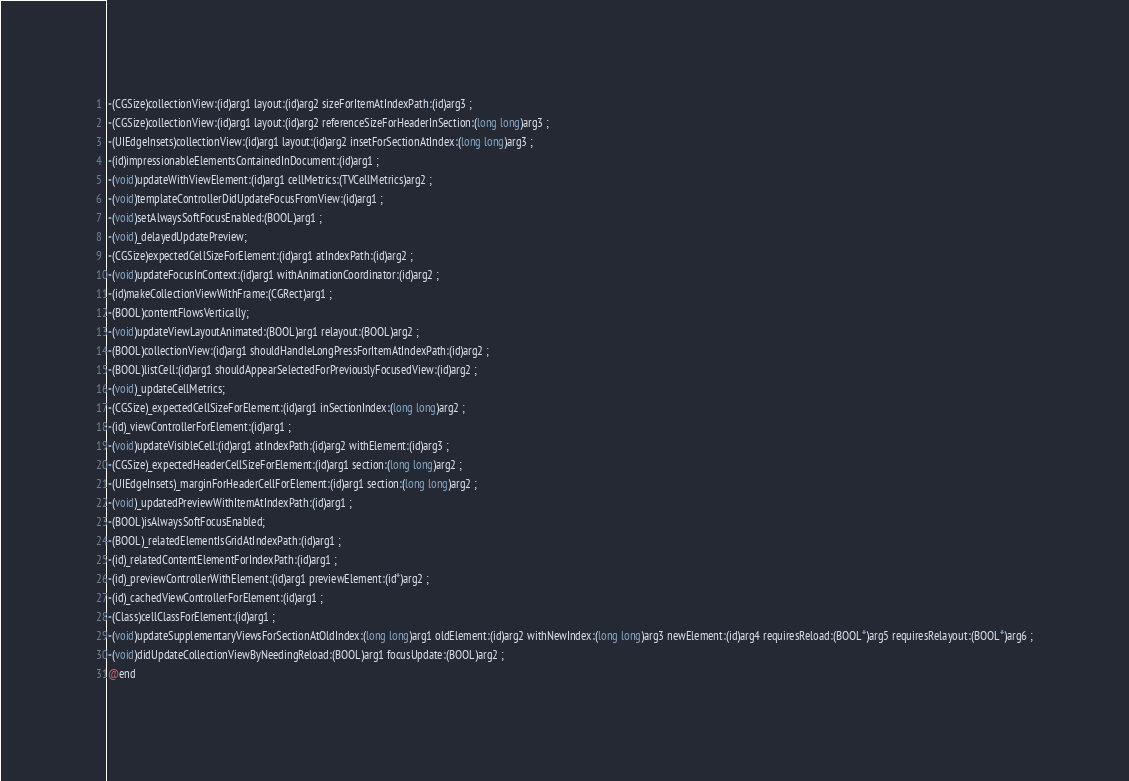Convert code to text. <code><loc_0><loc_0><loc_500><loc_500><_C_>-(CGSize)collectionView:(id)arg1 layout:(id)arg2 sizeForItemAtIndexPath:(id)arg3 ;
-(CGSize)collectionView:(id)arg1 layout:(id)arg2 referenceSizeForHeaderInSection:(long long)arg3 ;
-(UIEdgeInsets)collectionView:(id)arg1 layout:(id)arg2 insetForSectionAtIndex:(long long)arg3 ;
-(id)impressionableElementsContainedInDocument:(id)arg1 ;
-(void)updateWithViewElement:(id)arg1 cellMetrics:(TVCellMetrics)arg2 ;
-(void)templateControllerDidUpdateFocusFromView:(id)arg1 ;
-(void)setAlwaysSoftFocusEnabled:(BOOL)arg1 ;
-(void)_delayedUpdatePreview;
-(CGSize)expectedCellSizeForElement:(id)arg1 atIndexPath:(id)arg2 ;
-(void)updateFocusInContext:(id)arg1 withAnimationCoordinator:(id)arg2 ;
-(id)makeCollectionViewWithFrame:(CGRect)arg1 ;
-(BOOL)contentFlowsVertically;
-(void)updateViewLayoutAnimated:(BOOL)arg1 relayout:(BOOL)arg2 ;
-(BOOL)collectionView:(id)arg1 shouldHandleLongPressForItemAtIndexPath:(id)arg2 ;
-(BOOL)listCell:(id)arg1 shouldAppearSelectedForPreviouslyFocusedView:(id)arg2 ;
-(void)_updateCellMetrics;
-(CGSize)_expectedCellSizeForElement:(id)arg1 inSectionIndex:(long long)arg2 ;
-(id)_viewControllerForElement:(id)arg1 ;
-(void)updateVisibleCell:(id)arg1 atIndexPath:(id)arg2 withElement:(id)arg3 ;
-(CGSize)_expectedHeaderCellSizeForElement:(id)arg1 section:(long long)arg2 ;
-(UIEdgeInsets)_marginForHeaderCellForElement:(id)arg1 section:(long long)arg2 ;
-(void)_updatedPreviewWithItemAtIndexPath:(id)arg1 ;
-(BOOL)isAlwaysSoftFocusEnabled;
-(BOOL)_relatedElementIsGridAtIndexPath:(id)arg1 ;
-(id)_relatedContentElementForIndexPath:(id)arg1 ;
-(id)_previewControllerWithElement:(id)arg1 previewElement:(id*)arg2 ;
-(id)_cachedViewControllerForElement:(id)arg1 ;
-(Class)cellClassForElement:(id)arg1 ;
-(void)updateSupplementaryViewsForSectionAtOldIndex:(long long)arg1 oldElement:(id)arg2 withNewIndex:(long long)arg3 newElement:(id)arg4 requiresReload:(BOOL*)arg5 requiresRelayout:(BOOL*)arg6 ;
-(void)didUpdateCollectionViewByNeedingReload:(BOOL)arg1 focusUpdate:(BOOL)arg2 ;
@end

</code> 